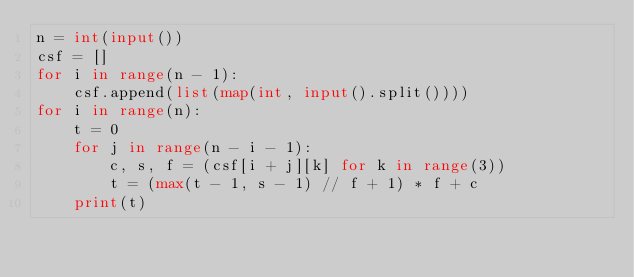<code> <loc_0><loc_0><loc_500><loc_500><_Python_>n = int(input())
csf = []
for i in range(n - 1):
    csf.append(list(map(int, input().split())))
for i in range(n):
    t = 0
    for j in range(n - i - 1):
        c, s, f = (csf[i + j][k] for k in range(3))
        t = (max(t - 1, s - 1) // f + 1) * f + c
    print(t)</code> 